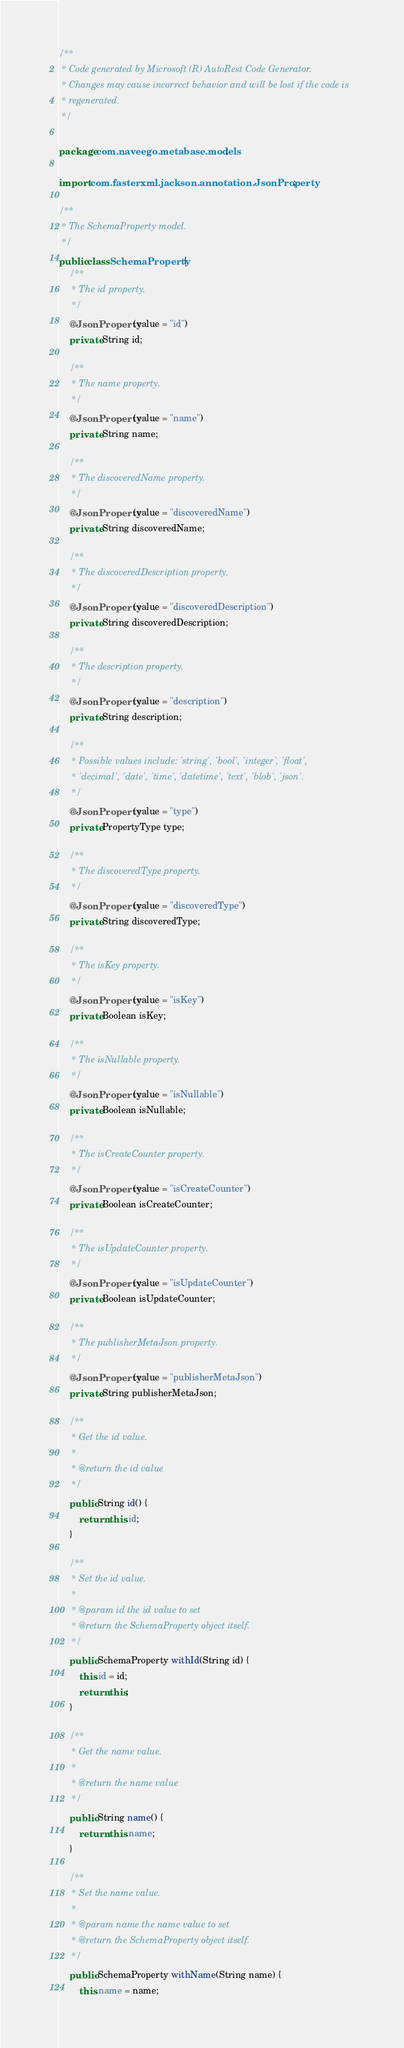<code> <loc_0><loc_0><loc_500><loc_500><_Java_>/**
 * Code generated by Microsoft (R) AutoRest Code Generator.
 * Changes may cause incorrect behavior and will be lost if the code is
 * regenerated.
 */

package com.naveego.metabase.models;

import com.fasterxml.jackson.annotation.JsonProperty;

/**
 * The SchemaProperty model.
 */
public class SchemaProperty {
    /**
     * The id property.
     */
    @JsonProperty(value = "id")
    private String id;

    /**
     * The name property.
     */
    @JsonProperty(value = "name")
    private String name;

    /**
     * The discoveredName property.
     */
    @JsonProperty(value = "discoveredName")
    private String discoveredName;

    /**
     * The discoveredDescription property.
     */
    @JsonProperty(value = "discoveredDescription")
    private String discoveredDescription;

    /**
     * The description property.
     */
    @JsonProperty(value = "description")
    private String description;

    /**
     * Possible values include: 'string', 'bool', 'integer', 'float',
     * 'decimal', 'date', 'time', 'datetime', 'text', 'blob', 'json'.
     */
    @JsonProperty(value = "type")
    private PropertyType type;

    /**
     * The discoveredType property.
     */
    @JsonProperty(value = "discoveredType")
    private String discoveredType;

    /**
     * The isKey property.
     */
    @JsonProperty(value = "isKey")
    private Boolean isKey;

    /**
     * The isNullable property.
     */
    @JsonProperty(value = "isNullable")
    private Boolean isNullable;

    /**
     * The isCreateCounter property.
     */
    @JsonProperty(value = "isCreateCounter")
    private Boolean isCreateCounter;

    /**
     * The isUpdateCounter property.
     */
    @JsonProperty(value = "isUpdateCounter")
    private Boolean isUpdateCounter;

    /**
     * The publisherMetaJson property.
     */
    @JsonProperty(value = "publisherMetaJson")
    private String publisherMetaJson;

    /**
     * Get the id value.
     *
     * @return the id value
     */
    public String id() {
        return this.id;
    }

    /**
     * Set the id value.
     *
     * @param id the id value to set
     * @return the SchemaProperty object itself.
     */
    public SchemaProperty withId(String id) {
        this.id = id;
        return this;
    }

    /**
     * Get the name value.
     *
     * @return the name value
     */
    public String name() {
        return this.name;
    }

    /**
     * Set the name value.
     *
     * @param name the name value to set
     * @return the SchemaProperty object itself.
     */
    public SchemaProperty withName(String name) {
        this.name = name;</code> 